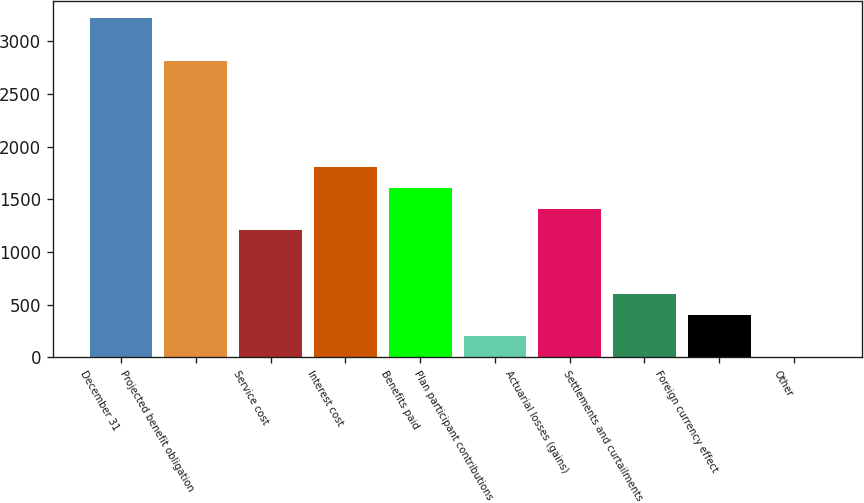Convert chart. <chart><loc_0><loc_0><loc_500><loc_500><bar_chart><fcel>December 31<fcel>Projected benefit obligation<fcel>Service cost<fcel>Interest cost<fcel>Benefits paid<fcel>Plan participant contributions<fcel>Actuarial losses (gains)<fcel>Settlements and curtailments<fcel>Foreign currency effect<fcel>Other<nl><fcel>3217.3<fcel>2815.2<fcel>1206.8<fcel>1809.95<fcel>1608.9<fcel>201.55<fcel>1407.85<fcel>603.65<fcel>402.6<fcel>0.5<nl></chart> 